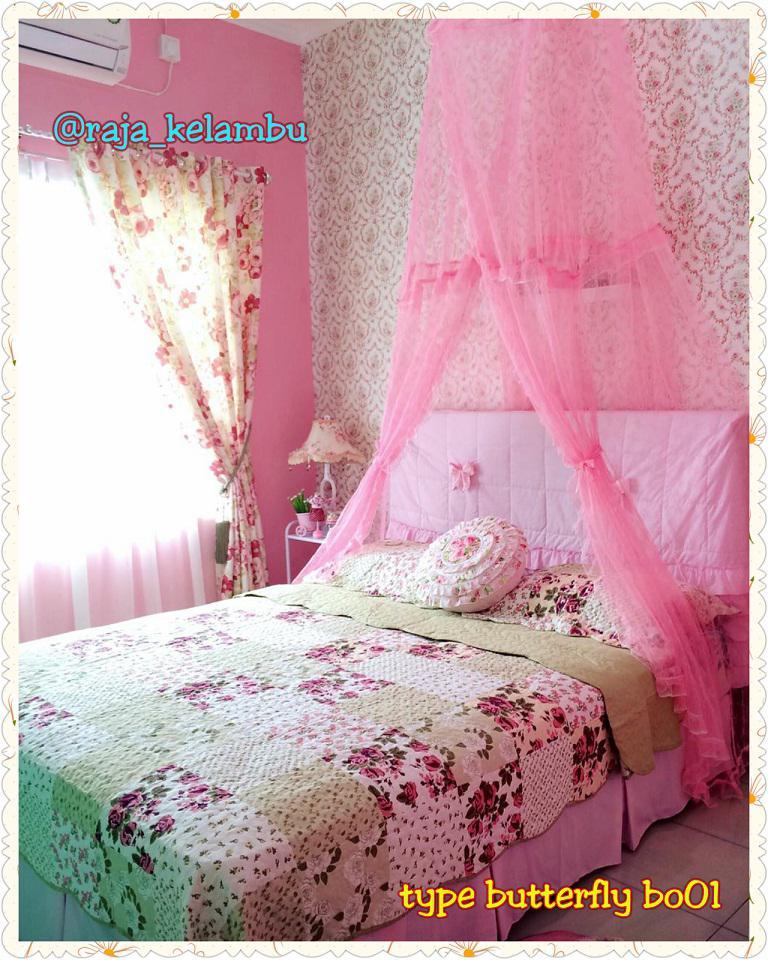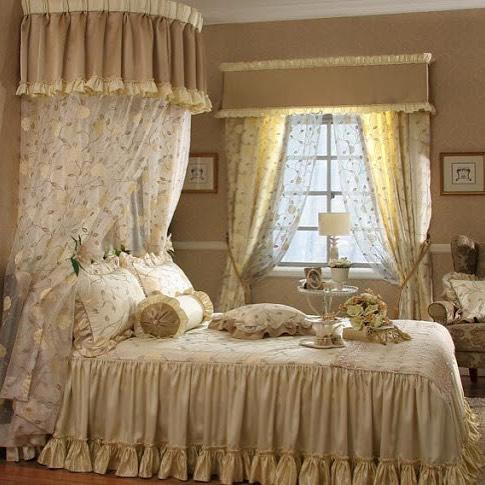The first image is the image on the left, the second image is the image on the right. For the images shown, is this caption "There are two purple bed canopies with headboards that are visible through them." true? Answer yes or no. No. The first image is the image on the left, the second image is the image on the right. For the images displayed, is the sentence "All of the bed nets are purple." factually correct? Answer yes or no. No. 